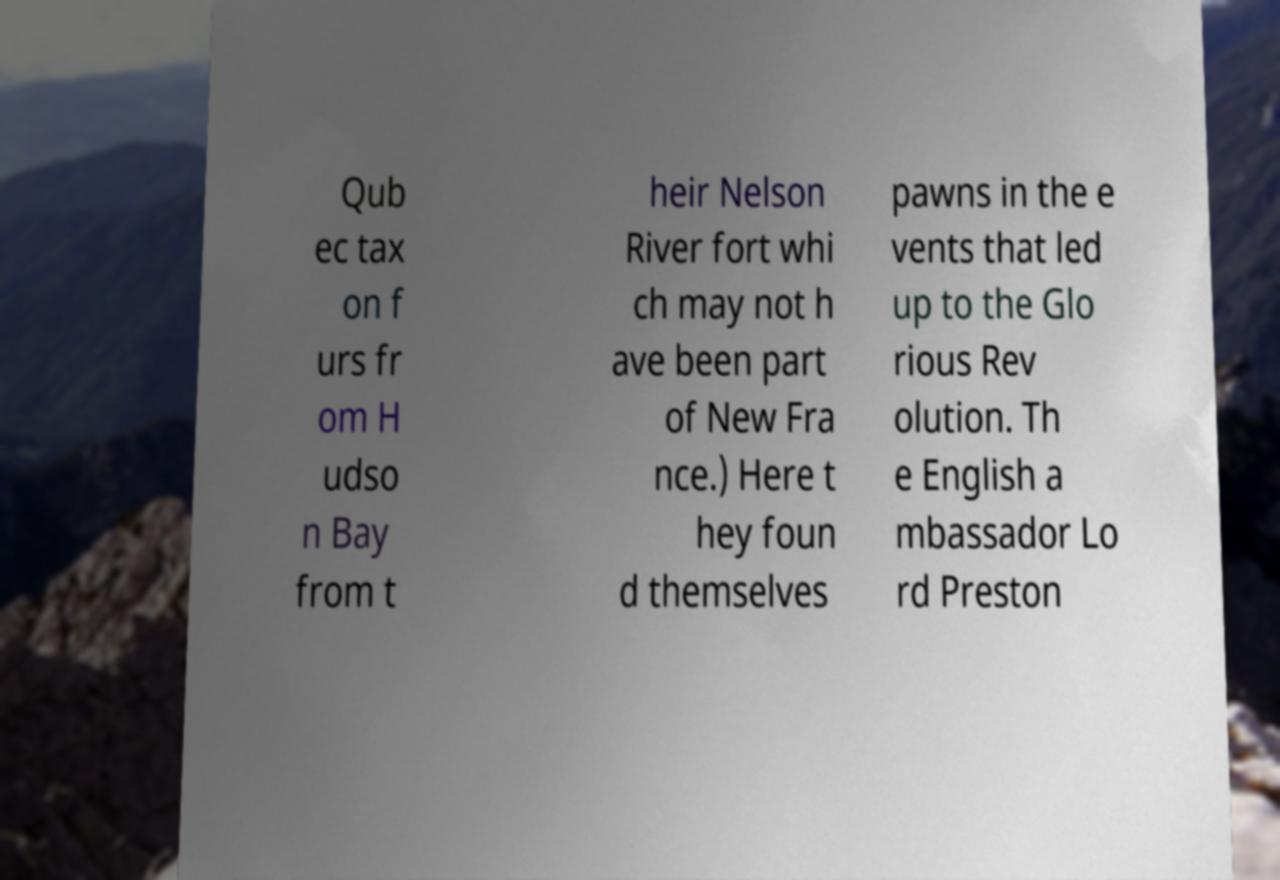I need the written content from this picture converted into text. Can you do that? Qub ec tax on f urs fr om H udso n Bay from t heir Nelson River fort whi ch may not h ave been part of New Fra nce.) Here t hey foun d themselves pawns in the e vents that led up to the Glo rious Rev olution. Th e English a mbassador Lo rd Preston 